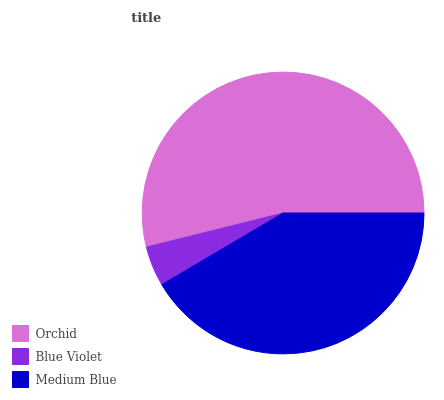Is Blue Violet the minimum?
Answer yes or no. Yes. Is Orchid the maximum?
Answer yes or no. Yes. Is Medium Blue the minimum?
Answer yes or no. No. Is Medium Blue the maximum?
Answer yes or no. No. Is Medium Blue greater than Blue Violet?
Answer yes or no. Yes. Is Blue Violet less than Medium Blue?
Answer yes or no. Yes. Is Blue Violet greater than Medium Blue?
Answer yes or no. No. Is Medium Blue less than Blue Violet?
Answer yes or no. No. Is Medium Blue the high median?
Answer yes or no. Yes. Is Medium Blue the low median?
Answer yes or no. Yes. Is Orchid the high median?
Answer yes or no. No. Is Blue Violet the low median?
Answer yes or no. No. 